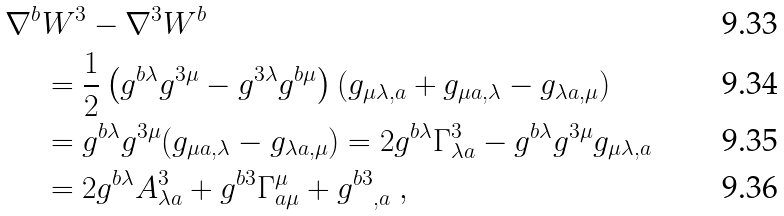<formula> <loc_0><loc_0><loc_500><loc_500>\nabla ^ { b } & W ^ { 3 } - \nabla ^ { 3 } W ^ { b } \\ & = \frac { 1 } { 2 } \left ( g ^ { b \lambda } g ^ { 3 \mu } - g ^ { 3 \lambda } g ^ { b \mu } \right ) ( g _ { \mu \lambda , a } + g _ { \mu a , \lambda } - g _ { \lambda a , \mu } ) \\ & = g ^ { b \lambda } g ^ { 3 \mu } ( g _ { \mu a , \lambda } - g _ { \lambda a , \mu } ) = 2 g ^ { b \lambda } \Gamma ^ { 3 } _ { \lambda a } - g ^ { b \lambda } g ^ { 3 \mu } g _ { \mu \lambda , a } \\ & = 2 g ^ { b \lambda } A ^ { 3 } _ { \lambda a } + g ^ { b 3 } \Gamma ^ { \mu } _ { a \mu } + { g ^ { b 3 } } _ { , a } \ ,</formula> 